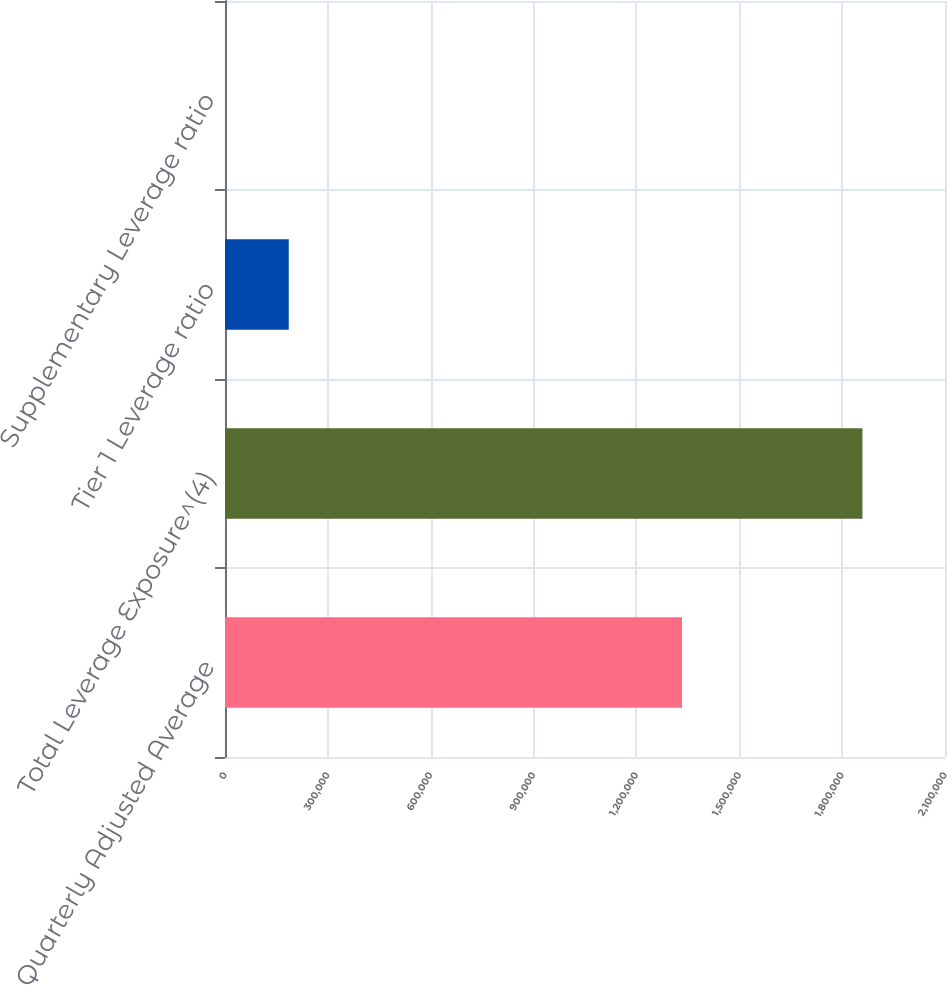Convert chart. <chart><loc_0><loc_0><loc_500><loc_500><bar_chart><fcel>Quarterly Adjusted Average<fcel>Total Leverage Exposure^(4)<fcel>Tier 1 Leverage ratio<fcel>Supplementary Leverage ratio<nl><fcel>1.33298e+06<fcel>1.85921e+06<fcel>185927<fcel>6.79<nl></chart> 